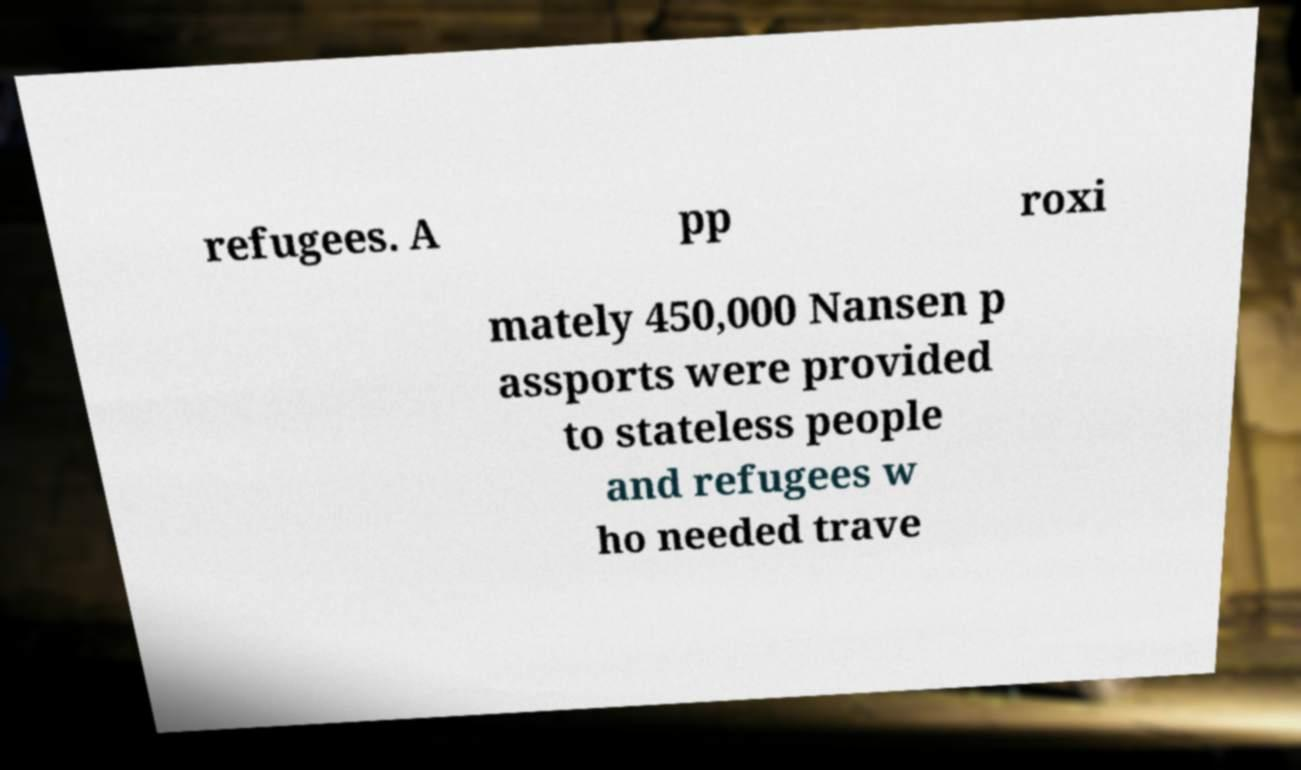I need the written content from this picture converted into text. Can you do that? refugees. A pp roxi mately 450,000 Nansen p assports were provided to stateless people and refugees w ho needed trave 